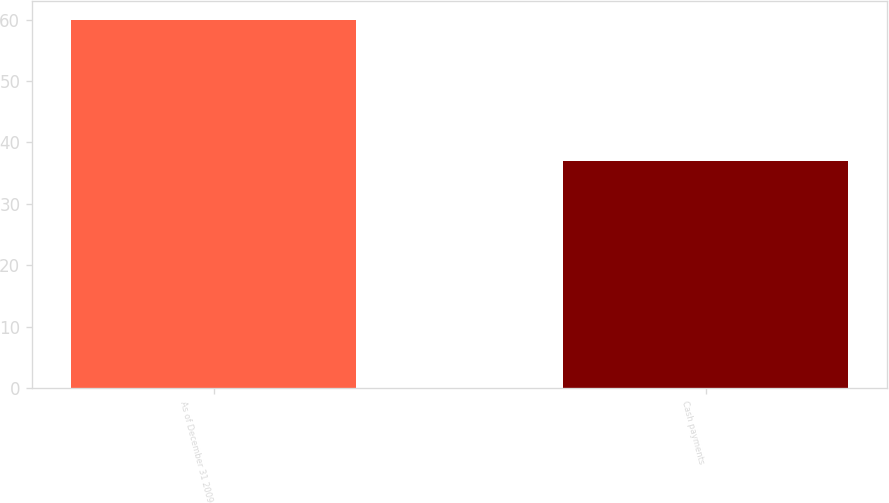<chart> <loc_0><loc_0><loc_500><loc_500><bar_chart><fcel>As of December 31 2009<fcel>Cash payments<nl><fcel>60<fcel>37<nl></chart> 